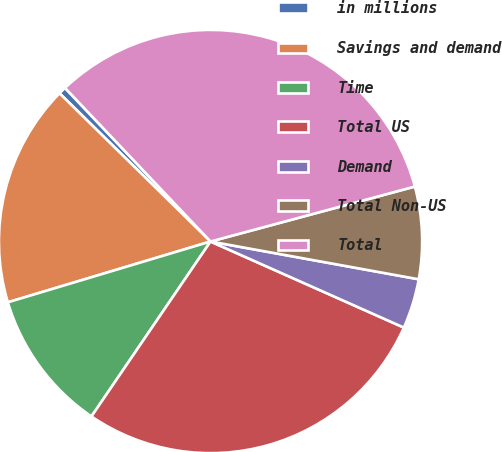Convert chart. <chart><loc_0><loc_0><loc_500><loc_500><pie_chart><fcel>in millions<fcel>Savings and demand<fcel>Time<fcel>Total US<fcel>Demand<fcel>Total Non-US<fcel>Total<nl><fcel>0.58%<fcel>16.99%<fcel>10.85%<fcel>27.85%<fcel>3.81%<fcel>7.04%<fcel>32.89%<nl></chart> 